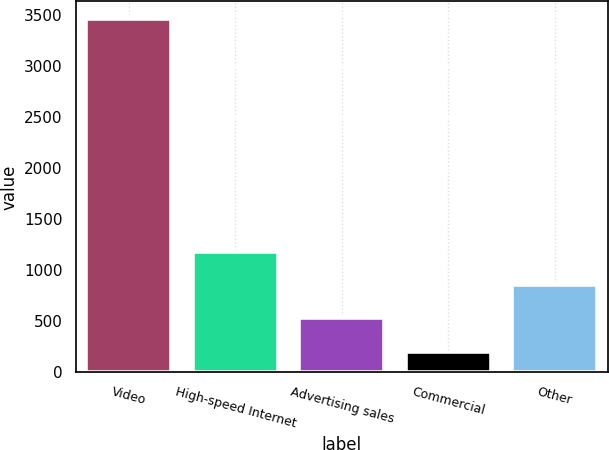<chart> <loc_0><loc_0><loc_500><loc_500><bar_chart><fcel>Video<fcel>High-speed Internet<fcel>Advertising sales<fcel>Commercial<fcel>Other<nl><fcel>3461<fcel>1181.1<fcel>529.7<fcel>204<fcel>855.4<nl></chart> 